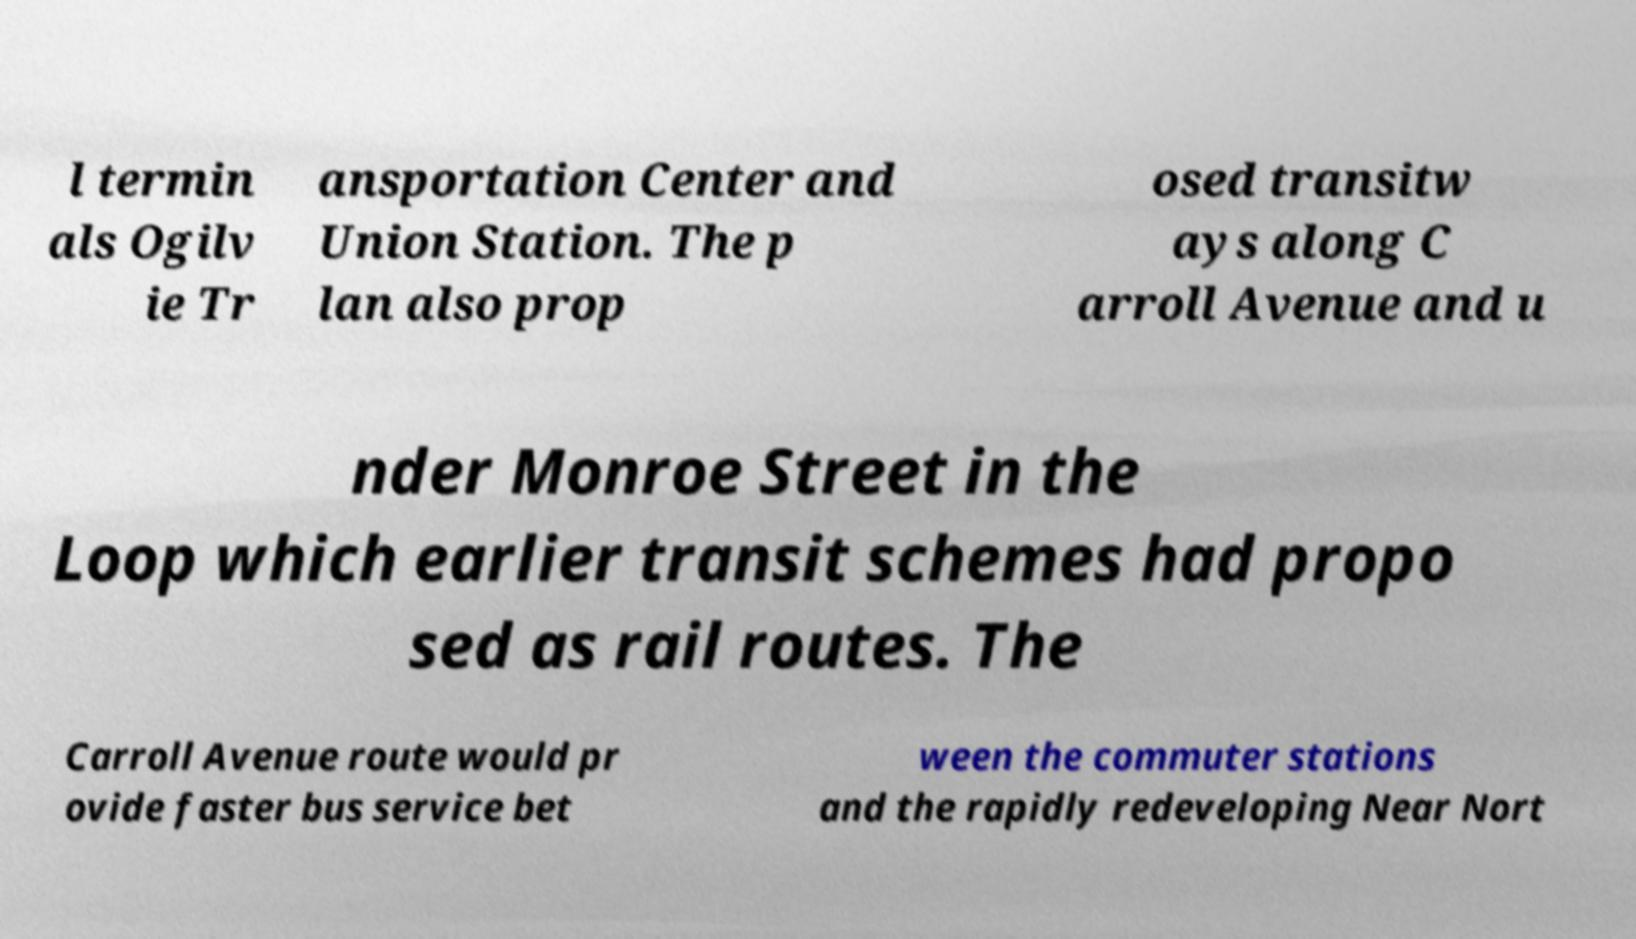There's text embedded in this image that I need extracted. Can you transcribe it verbatim? l termin als Ogilv ie Tr ansportation Center and Union Station. The p lan also prop osed transitw ays along C arroll Avenue and u nder Monroe Street in the Loop which earlier transit schemes had propo sed as rail routes. The Carroll Avenue route would pr ovide faster bus service bet ween the commuter stations and the rapidly redeveloping Near Nort 